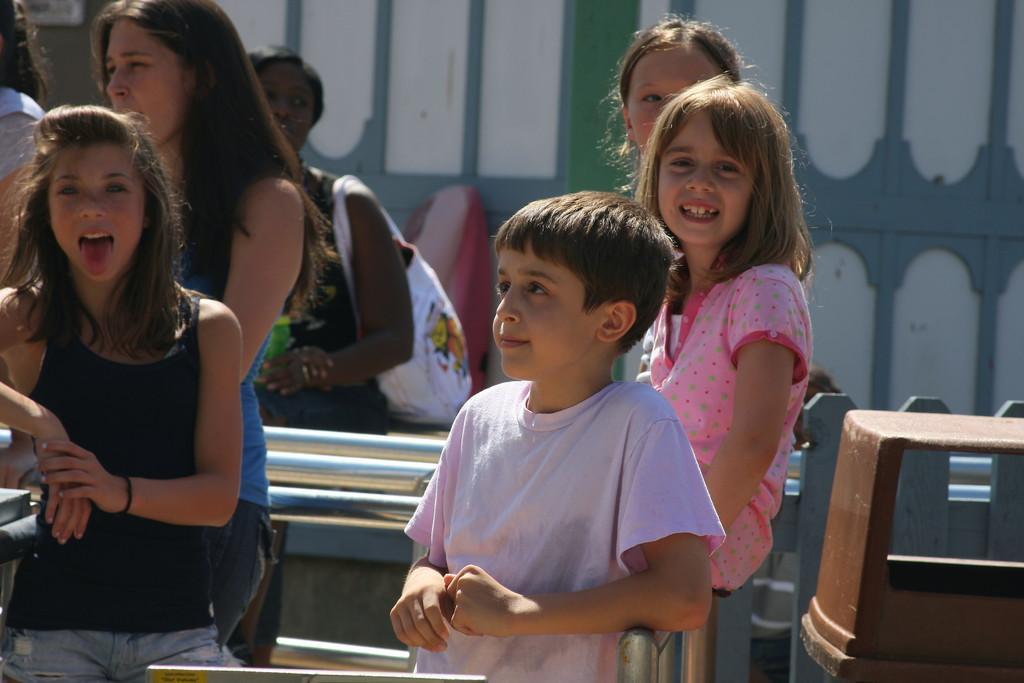Describe this image in one or two sentences. In the picture we can see two girls and one boy standing near the railing and behind them we can see one girl is standing and behind her we can see a person sitting and behind the person we can see a wall. 